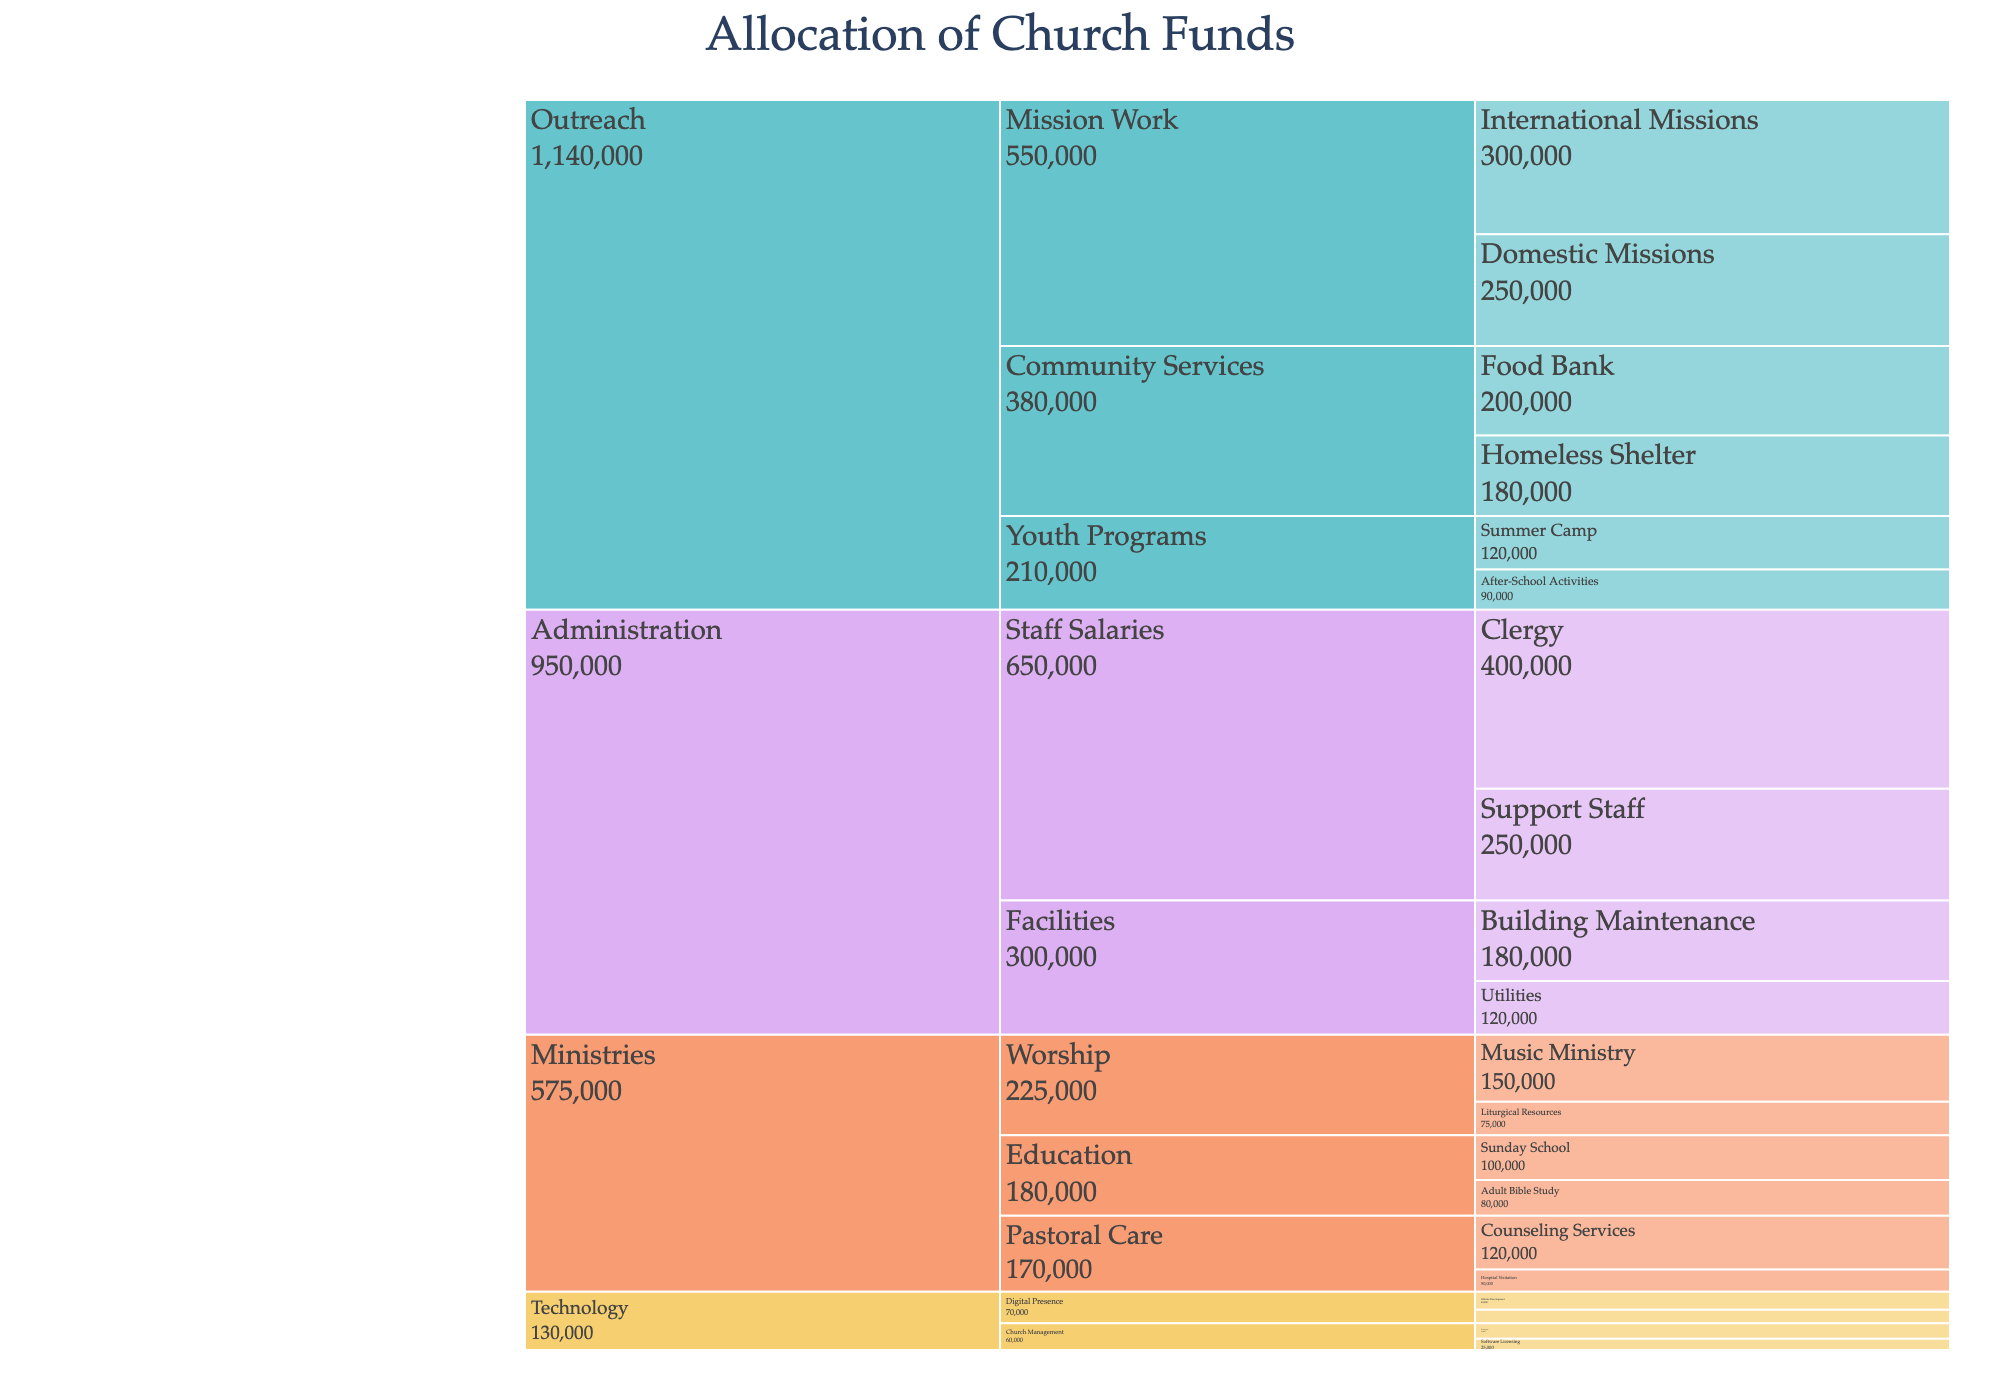What is the total allocation for the Worship subcategory? The Worship subcategory consists of Music Ministry and Liturgical Resources. Summing their amounts: 150,000 (Music Ministry) + 75,000 (Liturgical Resources) = 225,000.
Answer: 225,000 Which subcategory within Outreach has the highest allocation? Within Outreach, the subcategories are Community Services, Mission Work, and Youth Programs. To find the highest allocation, compare their total amounts: Community Services (200,000 + 180,000 = 380,000), Mission Work (250,000 + 300,000 = 550,000), and Youth Programs (120,000 + 90,000 = 210,000). Mission Work has the highest allocation with 550,000.
Answer: Mission Work How much more is allocated to Clergy compared to Support Staff? Clergy is allocated 400,000 and Support Staff is allocated 250,000. The difference is 400,000 - 250,000 = 150,000.
Answer: 150,000 What is the total amount allocated to the Technology category? Technology includes Digital Presence, Church Management, and their respective subcategories. Adding all amounts: Website Development (40,000) + Social Media Management (30,000) + Software Licensing (25,000) + IT Support (35,000) = 130,000.
Answer: 130,000 Which program within Community Services has a lower allocation? Community Services includes Food Bank and Homeless Shelter. Comparing their amounts: Food Bank (200,000) and Homeless Shelter (180,000). The Homeless Shelter has a lower allocation.
Answer: Homeless Shelter What is the difference in allocation between Domestic Missions and International Missions? Domestic Missions is allocated 250,000, and International Missions is allocated 300,000. The difference is 300,000 - 250,000 = 50,000.
Answer: 50,000 What is the total allocation for all categories under Ministries? Ministries include Worship (225,000), Education (180,000), and Pastoral Care (170,000). Adding these amounts: 225,000 + 180,000 + 170,000 = 575,000.
Answer: 575,000 Which program has the highest individual allocation and how much is it? Reviewing the amounts for each program, Clergy has the highest individual allocation with 400,000.
Answer: Clergy, 400,000 What is the total allocation for all programs under Outreach? Outreach includes Community Services (380,000), Mission Work (550,000), and Youth Programs (210,000). Adding these amounts: 380,000 + 550,000 + 210,000 = 1,140,000.
Answer: 1,140,000 